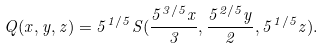<formula> <loc_0><loc_0><loc_500><loc_500>Q ( x , y , z ) = 5 ^ { 1 / 5 } S ( \frac { 5 ^ { 3 / 5 } x } { 3 } , \frac { 5 ^ { 2 / 5 } y } { 2 } , 5 ^ { 1 / 5 } z ) .</formula> 